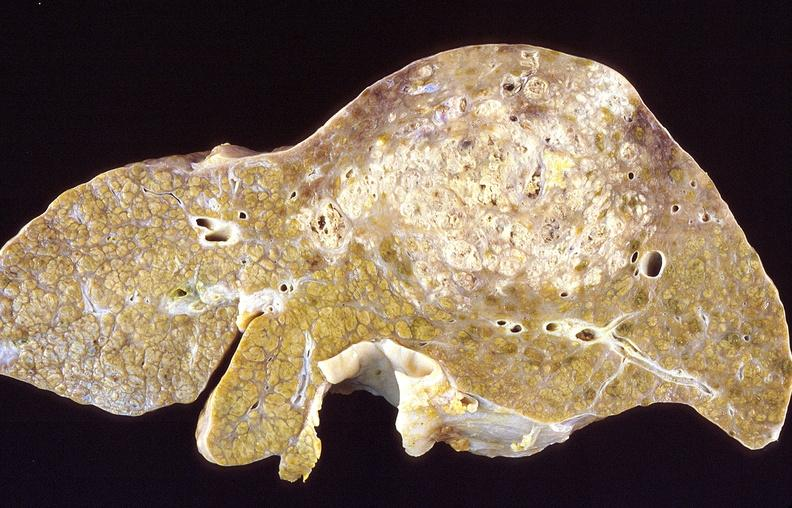what does this image show?
Answer the question using a single word or phrase. Hepatocellular carcinoma 